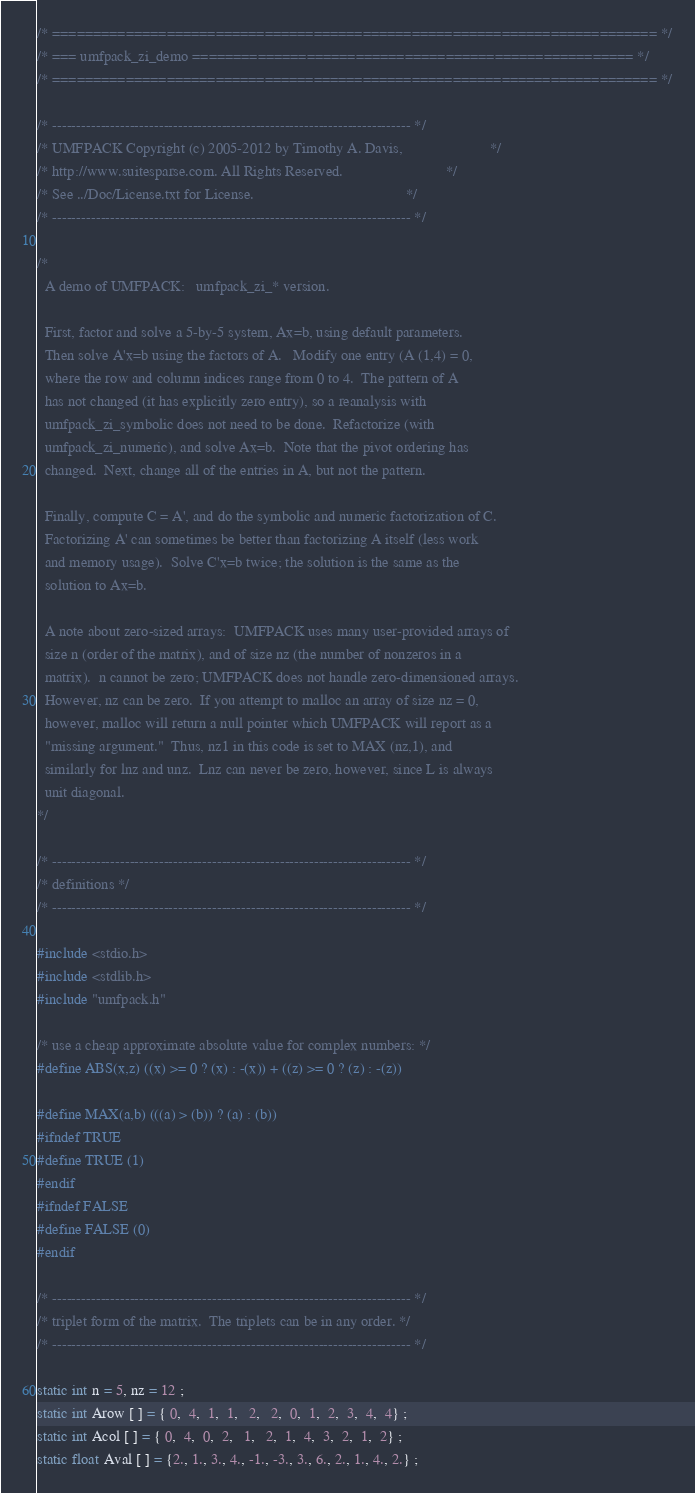<code> <loc_0><loc_0><loc_500><loc_500><_C_>/* ========================================================================== */
/* === umfpack_zi_demo ====================================================== */
/* ========================================================================== */

/* -------------------------------------------------------------------------- */
/* UMFPACK Copyright (c) 2005-2012 by Timothy A. Davis,                       */
/* http://www.suitesparse.com. All Rights Reserved.                           */
/* See ../Doc/License.txt for License.                                        */
/* -------------------------------------------------------------------------- */

/*
  A demo of UMFPACK:   umfpack_zi_* version.

  First, factor and solve a 5-by-5 system, Ax=b, using default parameters.
  Then solve A'x=b using the factors of A.   Modify one entry (A (1,4) = 0,
  where the row and column indices range from 0 to 4.  The pattern of A
  has not changed (it has explicitly zero entry), so a reanalysis with
  umfpack_zi_symbolic does not need to be done.  Refactorize (with
  umfpack_zi_numeric), and solve Ax=b.  Note that the pivot ordering has
  changed.  Next, change all of the entries in A, but not the pattern.

  Finally, compute C = A', and do the symbolic and numeric factorization of C.
  Factorizing A' can sometimes be better than factorizing A itself (less work
  and memory usage).  Solve C'x=b twice; the solution is the same as the
  solution to Ax=b.

  A note about zero-sized arrays:  UMFPACK uses many user-provided arrays of
  size n (order of the matrix), and of size nz (the number of nonzeros in a
  matrix).  n cannot be zero; UMFPACK does not handle zero-dimensioned arrays.
  However, nz can be zero.  If you attempt to malloc an array of size nz = 0,
  however, malloc will return a null pointer which UMFPACK will report as a
  "missing argument."  Thus, nz1 in this code is set to MAX (nz,1), and
  similarly for lnz and unz.  Lnz can never be zero, however, since L is always
  unit diagonal.
*/

/* -------------------------------------------------------------------------- */
/* definitions */
/* -------------------------------------------------------------------------- */

#include <stdio.h>
#include <stdlib.h>
#include "umfpack.h"

/* use a cheap approximate absolute value for complex numbers: */
#define ABS(x,z) ((x) >= 0 ? (x) : -(x)) + ((z) >= 0 ? (z) : -(z))

#define MAX(a,b) (((a) > (b)) ? (a) : (b))
#ifndef TRUE
#define TRUE (1)
#endif
#ifndef FALSE
#define FALSE (0)
#endif

/* -------------------------------------------------------------------------- */
/* triplet form of the matrix.  The triplets can be in any order. */
/* -------------------------------------------------------------------------- */

static int n = 5, nz = 12 ;
static int Arow [ ] = { 0,  4,  1,  1,   2,   2,  0,  1,  2,  3,  4,  4} ;
static int Acol [ ] = { 0,  4,  0,  2,   1,   2,  1,  4,  3,  2,  1,  2} ;
static float Aval [ ] = {2., 1., 3., 4., -1., -3., 3., 6., 2., 1., 4., 2.} ;</code> 